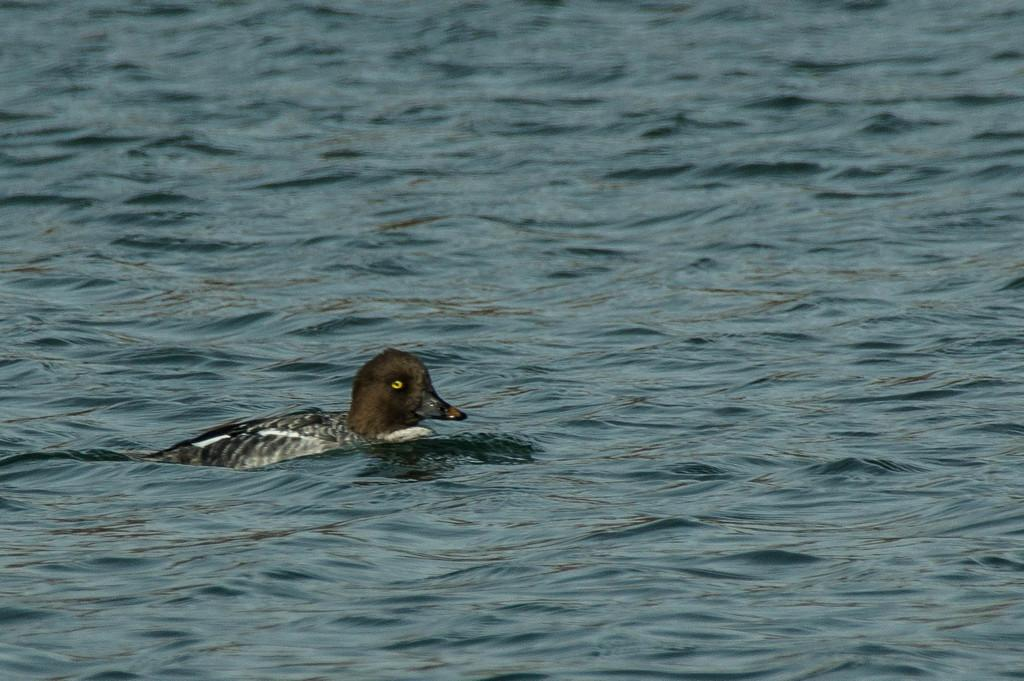What animal is present in the image? There is a duck in the image. Where is the duck located? The duck is on the water. What type of government is depicted in the image? There is no depiction of a government in the image; it features a duck on the water. Can you see a border in the image? There is no border present in the image; it features a duck on the water. 